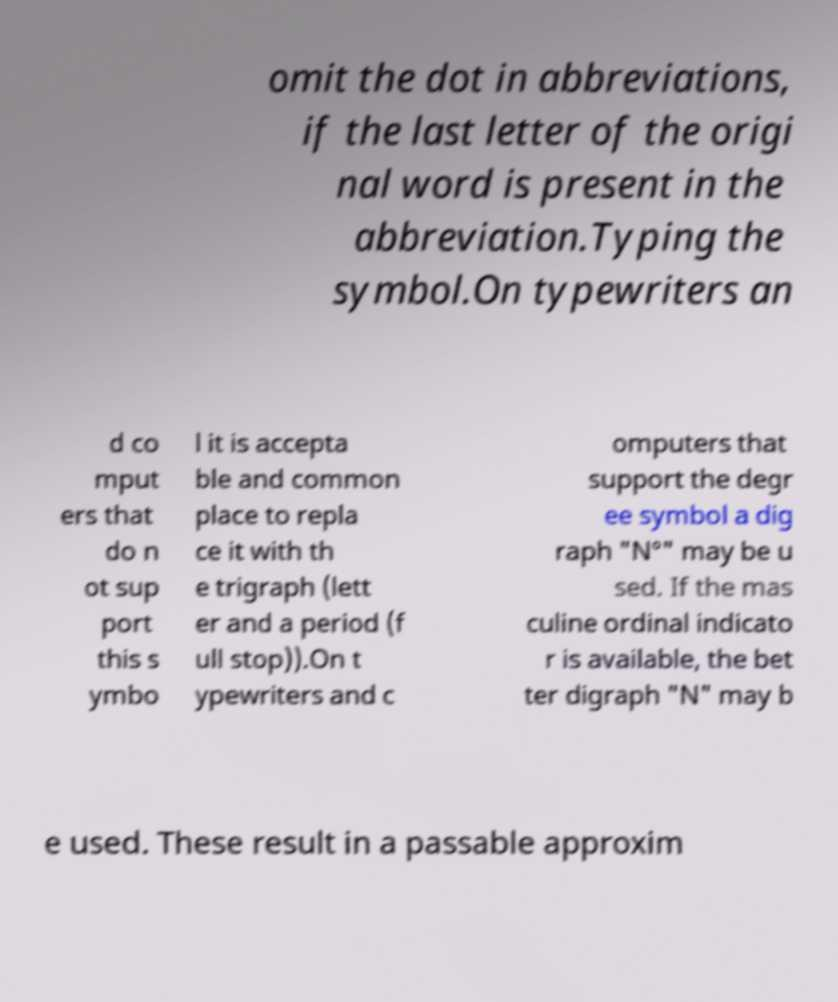I need the written content from this picture converted into text. Can you do that? omit the dot in abbreviations, if the last letter of the origi nal word is present in the abbreviation.Typing the symbol.On typewriters an d co mput ers that do n ot sup port this s ymbo l it is accepta ble and common place to repla ce it with th e trigraph (lett er and a period (f ull stop)).On t ypewriters and c omputers that support the degr ee symbol a dig raph "N°" may be u sed. If the mas culine ordinal indicato r is available, the bet ter digraph "N" may b e used. These result in a passable approxim 